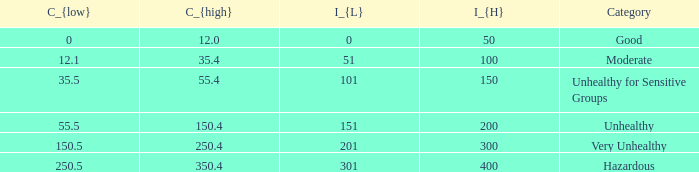How many different C_{high} values are there for the good category? 1.0. 